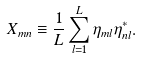Convert formula to latex. <formula><loc_0><loc_0><loc_500><loc_500>X _ { m n } \equiv \frac { 1 } { L } \sum _ { l = 1 } ^ { L } \eta _ { m l } \eta ^ { * } _ { n l } .</formula> 